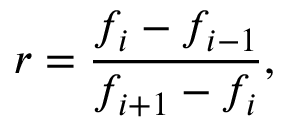<formula> <loc_0><loc_0><loc_500><loc_500>r = \frac { f _ { i } - f _ { i - 1 } } { f _ { i + 1 } - f _ { i } } ,</formula> 